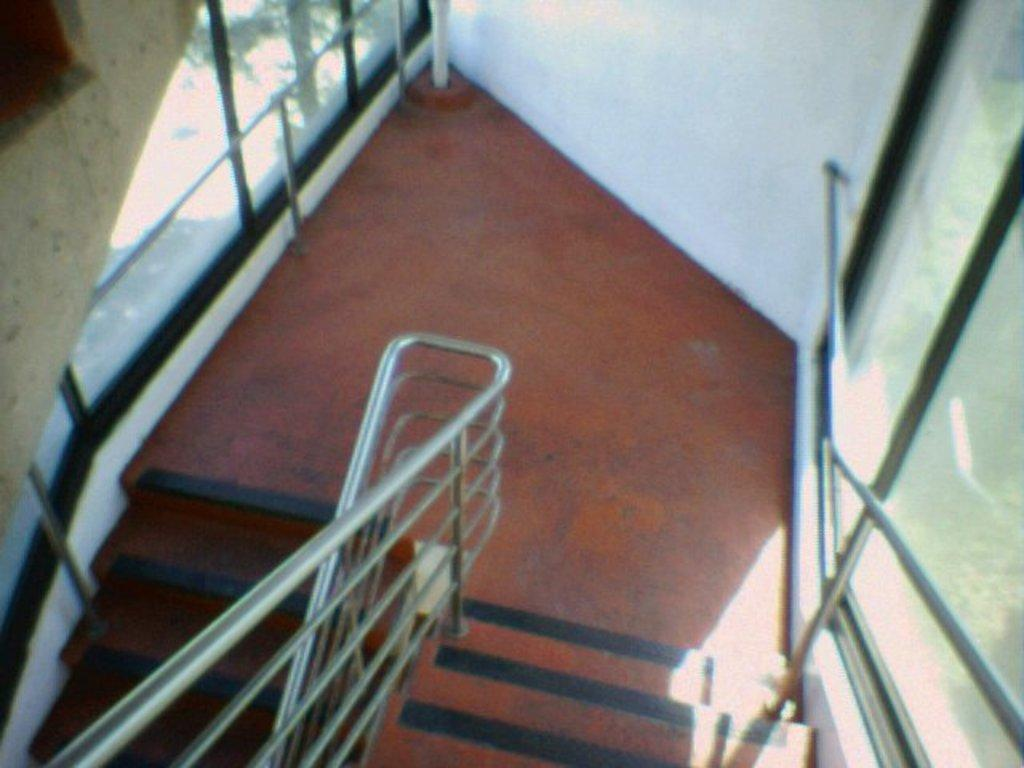What type of architectural feature is present in the image? There are stairs in the image. What safety feature is included with the stairs? There is a railing in the image. What material is present on both sides of the image? A: There is glass on both the right and left sides of the image. What is located at the top of the image? There is a wall at the top of the image. How many servants can be seen working in the image? There are no servants present in the image. What type of laborer is visible in the image? There are no laborers present in the image. 